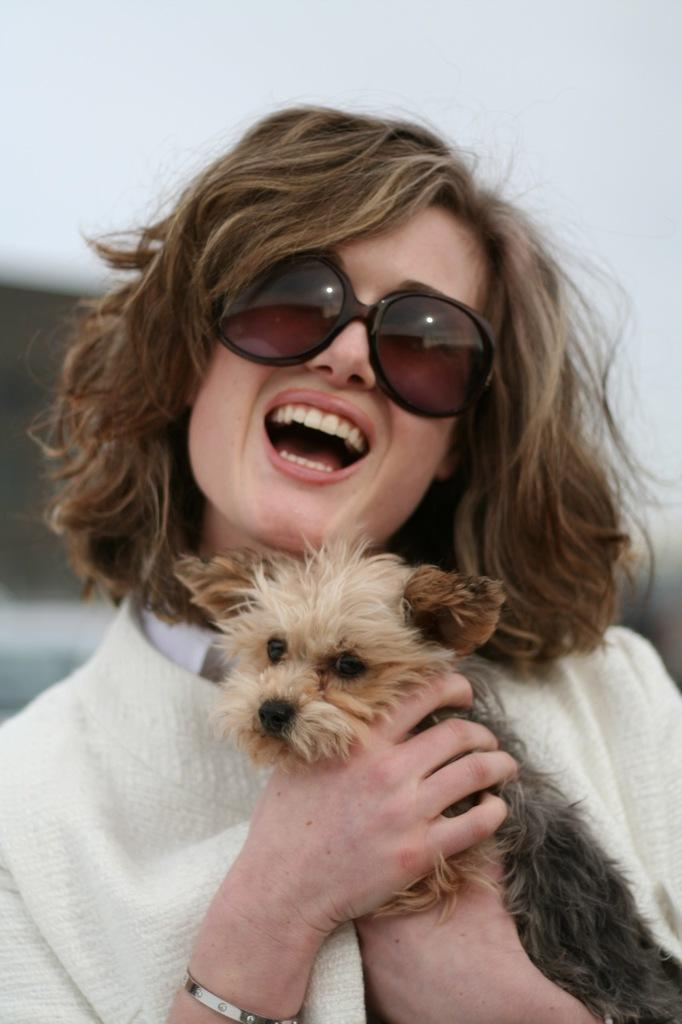Who is the main subject of the subject in the image? There is a woman in the image. What is the woman wearing? The woman is wearing a white coat. What is the woman holding in the image? The woman is holding a cat. What accessory is the woman wearing? The woman is wearing glasses. What is the color of the background in the image? The background of the image is white. How many bikes are visible in the image? There are no bikes present in the image. What type of copy is the woman making in the image? There is no copying or writing activity depicted in the image; the woman is holding a cat. 